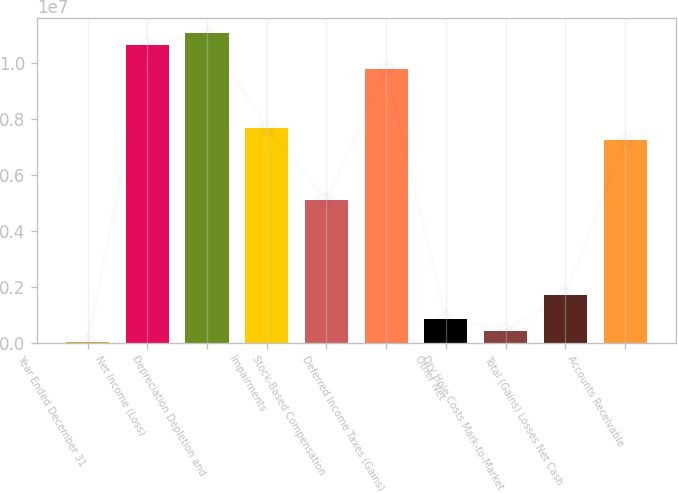Convert chart to OTSL. <chart><loc_0><loc_0><loc_500><loc_500><bar_chart><fcel>Year Ended December 31<fcel>Net Income (Loss)<fcel>Depreciation Depletion and<fcel>Impairments<fcel>Stock-Based Compensation<fcel>Deferred Income Taxes (Gains)<fcel>Other Net<fcel>Dry Hole Costs Mark-to-Market<fcel>Total (Gains) Losses Net Cash<fcel>Accounts Receivable<nl><fcel>2017<fcel>1.06603e+07<fcel>1.10866e+07<fcel>7.67599e+06<fcel>5.118e+06<fcel>9.80765e+06<fcel>854681<fcel>428349<fcel>1.70734e+06<fcel>7.24966e+06<nl></chart> 